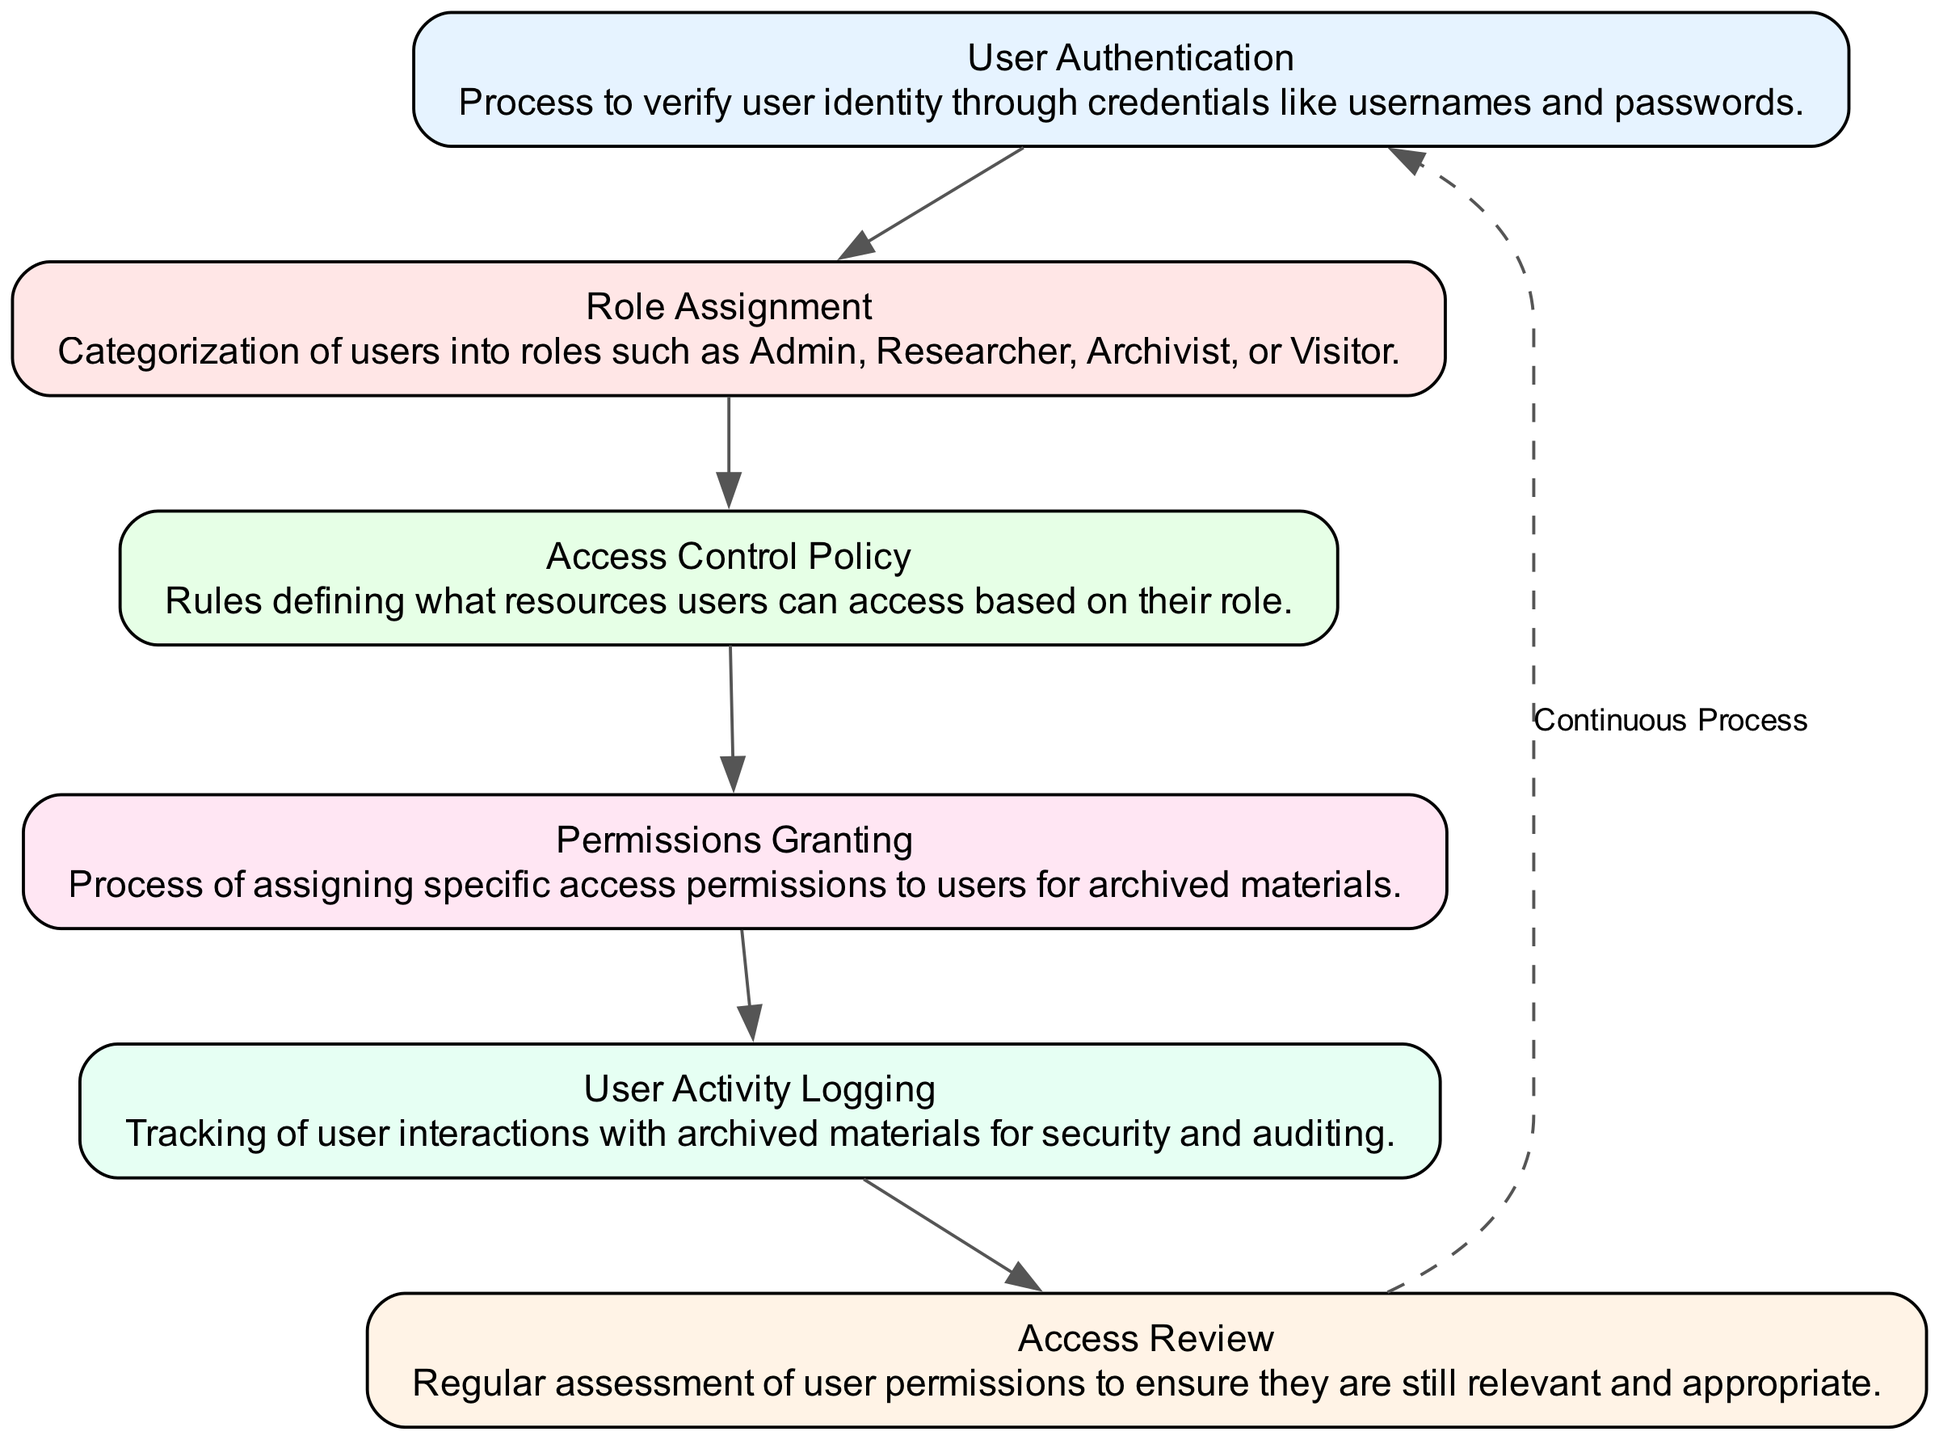What is the first step in the user's access management process? The first step in the flow chart is "User Authentication", which is the initial process to verify the user's identity.
Answer: User Authentication How many main elements are displayed in the diagram? There are a total of 6 main elements in the diagram representing different processes in user access management.
Answer: 6 What is the role of "Role Assignment"? "Role Assignment" categorizes users into different roles such as Admin, Researcher, Archivist, or Visitor, determining their access level.
Answer: Categorization of users What is the last step before returning to the first node? The last step before returning to the first node is "Access Review", which involves assessing user permissions for their relevance and appropriateness.
Answer: Access Review Which two nodes are directly connected to the "Permissions Granting"? "Role Assignment" comes before "Permissions Granting", and "User Activity Logging" follows afterward, representing a direct connection to both processes.
Answer: Role Assignment, User Activity Logging What type of feedback mechanism is indicated between the last and first nodes? The diagram shows a dashed line labeled 'Continuous Process', indicating an iterative feedback loop that connects "Access Review" back to "User Authentication".
Answer: Continuous Process How does "User Activity Logging" contribute to the overall management process? "User Activity Logging" tracks interactions with archived materials, which aids in security and auditing, thus enhancing overall management.
Answer: Security and auditing What connects "Access Control Policy" to "Permissions Granting"? The flow chart illustrates that after "Access Control Policy" is established, it leads directly to the "Permissions Granting" process, indicating a sequential relationship.
Answer: Direct connection What is the purpose of "Access Control Policy"? The "Access Control Policy" defines rules about what resources users can access based on their assigned roles, guiding the permissions granted.
Answer: Rule definition for access 